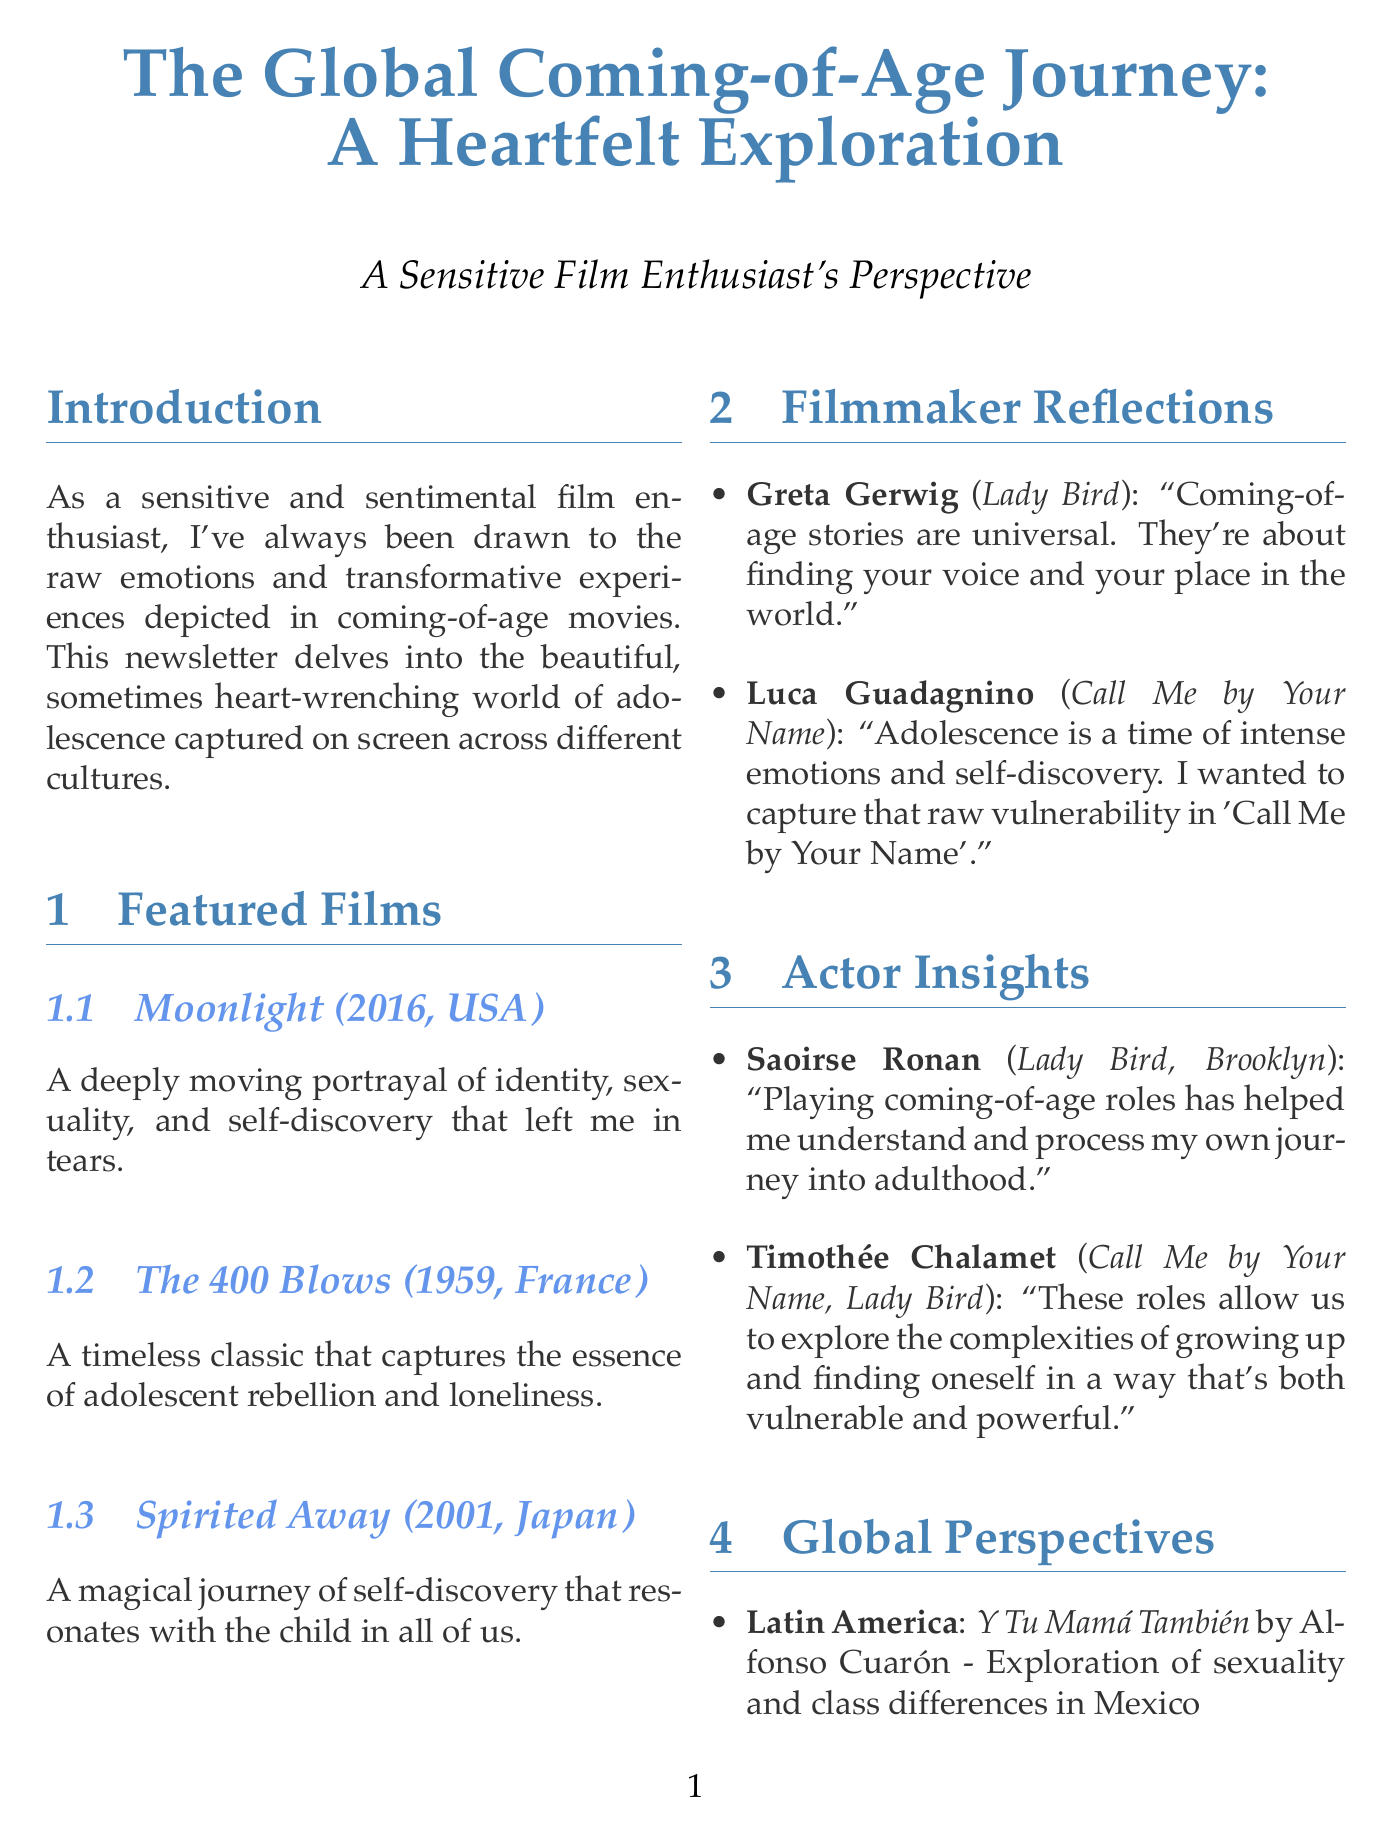what is the title of the newsletter? The title of the newsletter is mentioned clearly at the top of the document.
Answer: The Global Coming-of-Age Journey: A Heartfelt Exploration who directed "Moonlight"? The name of the director of "Moonlight" is listed under the featured films section.
Answer: Barry Jenkins which film explores sexuality and class differences in Mexico? This film is mentioned in the global perspectives section with its corresponding theme.
Answer: Y Tu Mamá También what year was "The 400 Blows" released? The release year is provided in the featured films section for each mentioned film.
Answer: 1959 who stated that coming-of-age stories are universal? This quote is attributed to a filmmaker in the reflections section.
Answer: Greta Gerwig how many films are discussed in the featured films section? This information can be determined from counting the listed films.
Answer: 3 what region is associated with the film "Wadjda"? The region for each listed film in the global perspectives can be found in the document.
Answer: Middle East what theme is explored in the film "Tsotsi"? The theme is specifically mentioned alongside the film and its director.
Answer: Redemption and responsibility in post-apartheid South Africa how does the newsletter categorize perspectives on coming-of-age films? The document organizes perspectives by geographic regions.
Answer: Global Perspectives 